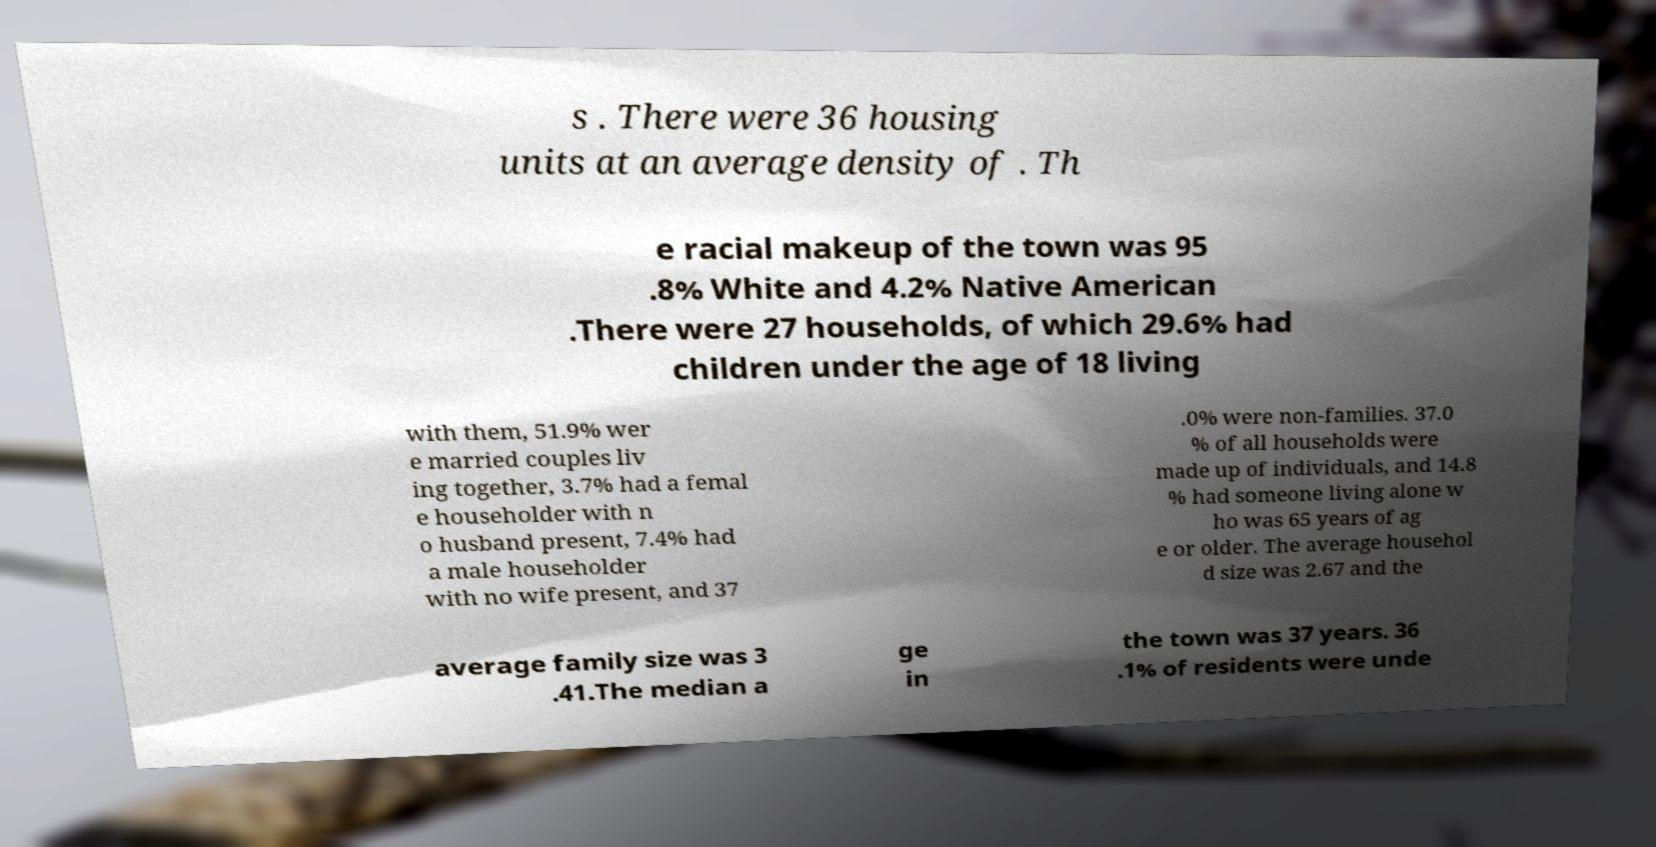Could you extract and type out the text from this image? s . There were 36 housing units at an average density of . Th e racial makeup of the town was 95 .8% White and 4.2% Native American .There were 27 households, of which 29.6% had children under the age of 18 living with them, 51.9% wer e married couples liv ing together, 3.7% had a femal e householder with n o husband present, 7.4% had a male householder with no wife present, and 37 .0% were non-families. 37.0 % of all households were made up of individuals, and 14.8 % had someone living alone w ho was 65 years of ag e or older. The average househol d size was 2.67 and the average family size was 3 .41.The median a ge in the town was 37 years. 36 .1% of residents were unde 